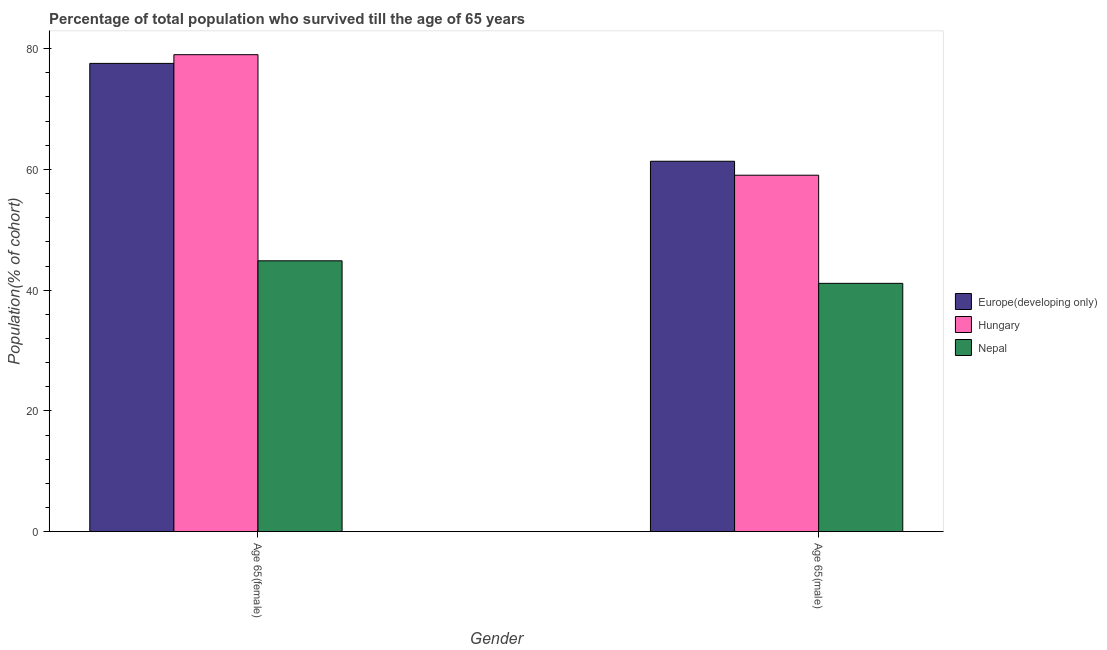How many different coloured bars are there?
Keep it short and to the point. 3. How many groups of bars are there?
Make the answer very short. 2. Are the number of bars per tick equal to the number of legend labels?
Offer a terse response. Yes. Are the number of bars on each tick of the X-axis equal?
Your answer should be very brief. Yes. How many bars are there on the 1st tick from the left?
Your answer should be compact. 3. What is the label of the 1st group of bars from the left?
Your answer should be compact. Age 65(female). What is the percentage of female population who survived till age of 65 in Hungary?
Ensure brevity in your answer.  79. Across all countries, what is the maximum percentage of male population who survived till age of 65?
Offer a terse response. 61.35. Across all countries, what is the minimum percentage of male population who survived till age of 65?
Your answer should be compact. 41.13. In which country was the percentage of female population who survived till age of 65 maximum?
Your response must be concise. Hungary. In which country was the percentage of female population who survived till age of 65 minimum?
Keep it short and to the point. Nepal. What is the total percentage of female population who survived till age of 65 in the graph?
Offer a very short reply. 201.42. What is the difference between the percentage of female population who survived till age of 65 in Europe(developing only) and that in Nepal?
Your response must be concise. 32.69. What is the difference between the percentage of male population who survived till age of 65 in Nepal and the percentage of female population who survived till age of 65 in Europe(developing only)?
Ensure brevity in your answer.  -36.43. What is the average percentage of female population who survived till age of 65 per country?
Give a very brief answer. 67.14. What is the difference between the percentage of male population who survived till age of 65 and percentage of female population who survived till age of 65 in Nepal?
Keep it short and to the point. -3.74. In how many countries, is the percentage of male population who survived till age of 65 greater than 76 %?
Offer a very short reply. 0. What is the ratio of the percentage of female population who survived till age of 65 in Nepal to that in Europe(developing only)?
Offer a very short reply. 0.58. In how many countries, is the percentage of female population who survived till age of 65 greater than the average percentage of female population who survived till age of 65 taken over all countries?
Your answer should be very brief. 2. What does the 2nd bar from the left in Age 65(male) represents?
Provide a succinct answer. Hungary. What does the 3rd bar from the right in Age 65(male) represents?
Offer a very short reply. Europe(developing only). How many bars are there?
Your response must be concise. 6. How many countries are there in the graph?
Give a very brief answer. 3. Does the graph contain any zero values?
Your answer should be very brief. No. What is the title of the graph?
Make the answer very short. Percentage of total population who survived till the age of 65 years. What is the label or title of the X-axis?
Give a very brief answer. Gender. What is the label or title of the Y-axis?
Provide a short and direct response. Population(% of cohort). What is the Population(% of cohort) in Europe(developing only) in Age 65(female)?
Your answer should be compact. 77.55. What is the Population(% of cohort) in Hungary in Age 65(female)?
Your answer should be very brief. 79. What is the Population(% of cohort) in Nepal in Age 65(female)?
Your response must be concise. 44.86. What is the Population(% of cohort) of Europe(developing only) in Age 65(male)?
Offer a very short reply. 61.35. What is the Population(% of cohort) of Hungary in Age 65(male)?
Offer a very short reply. 59.04. What is the Population(% of cohort) in Nepal in Age 65(male)?
Ensure brevity in your answer.  41.13. Across all Gender, what is the maximum Population(% of cohort) in Europe(developing only)?
Your response must be concise. 77.55. Across all Gender, what is the maximum Population(% of cohort) of Hungary?
Keep it short and to the point. 79. Across all Gender, what is the maximum Population(% of cohort) in Nepal?
Offer a terse response. 44.86. Across all Gender, what is the minimum Population(% of cohort) in Europe(developing only)?
Offer a terse response. 61.35. Across all Gender, what is the minimum Population(% of cohort) in Hungary?
Offer a terse response. 59.04. Across all Gender, what is the minimum Population(% of cohort) of Nepal?
Keep it short and to the point. 41.13. What is the total Population(% of cohort) of Europe(developing only) in the graph?
Make the answer very short. 138.9. What is the total Population(% of cohort) in Hungary in the graph?
Offer a terse response. 138.03. What is the total Population(% of cohort) of Nepal in the graph?
Make the answer very short. 85.99. What is the difference between the Population(% of cohort) in Europe(developing only) in Age 65(female) and that in Age 65(male)?
Provide a succinct answer. 16.2. What is the difference between the Population(% of cohort) of Hungary in Age 65(female) and that in Age 65(male)?
Offer a terse response. 19.96. What is the difference between the Population(% of cohort) in Nepal in Age 65(female) and that in Age 65(male)?
Your answer should be compact. 3.74. What is the difference between the Population(% of cohort) in Europe(developing only) in Age 65(female) and the Population(% of cohort) in Hungary in Age 65(male)?
Provide a succinct answer. 18.52. What is the difference between the Population(% of cohort) in Europe(developing only) in Age 65(female) and the Population(% of cohort) in Nepal in Age 65(male)?
Provide a short and direct response. 36.43. What is the difference between the Population(% of cohort) in Hungary in Age 65(female) and the Population(% of cohort) in Nepal in Age 65(male)?
Give a very brief answer. 37.87. What is the average Population(% of cohort) in Europe(developing only) per Gender?
Give a very brief answer. 69.45. What is the average Population(% of cohort) of Hungary per Gender?
Provide a short and direct response. 69.02. What is the average Population(% of cohort) in Nepal per Gender?
Offer a terse response. 43. What is the difference between the Population(% of cohort) of Europe(developing only) and Population(% of cohort) of Hungary in Age 65(female)?
Provide a succinct answer. -1.45. What is the difference between the Population(% of cohort) of Europe(developing only) and Population(% of cohort) of Nepal in Age 65(female)?
Offer a terse response. 32.69. What is the difference between the Population(% of cohort) of Hungary and Population(% of cohort) of Nepal in Age 65(female)?
Offer a terse response. 34.14. What is the difference between the Population(% of cohort) of Europe(developing only) and Population(% of cohort) of Hungary in Age 65(male)?
Provide a succinct answer. 2.31. What is the difference between the Population(% of cohort) in Europe(developing only) and Population(% of cohort) in Nepal in Age 65(male)?
Your answer should be compact. 20.22. What is the difference between the Population(% of cohort) in Hungary and Population(% of cohort) in Nepal in Age 65(male)?
Ensure brevity in your answer.  17.91. What is the ratio of the Population(% of cohort) of Europe(developing only) in Age 65(female) to that in Age 65(male)?
Ensure brevity in your answer.  1.26. What is the ratio of the Population(% of cohort) of Hungary in Age 65(female) to that in Age 65(male)?
Offer a terse response. 1.34. What is the ratio of the Population(% of cohort) of Nepal in Age 65(female) to that in Age 65(male)?
Offer a very short reply. 1.09. What is the difference between the highest and the second highest Population(% of cohort) of Europe(developing only)?
Your answer should be compact. 16.2. What is the difference between the highest and the second highest Population(% of cohort) in Hungary?
Your response must be concise. 19.96. What is the difference between the highest and the second highest Population(% of cohort) in Nepal?
Keep it short and to the point. 3.74. What is the difference between the highest and the lowest Population(% of cohort) of Europe(developing only)?
Provide a succinct answer. 16.2. What is the difference between the highest and the lowest Population(% of cohort) of Hungary?
Offer a very short reply. 19.96. What is the difference between the highest and the lowest Population(% of cohort) in Nepal?
Keep it short and to the point. 3.74. 